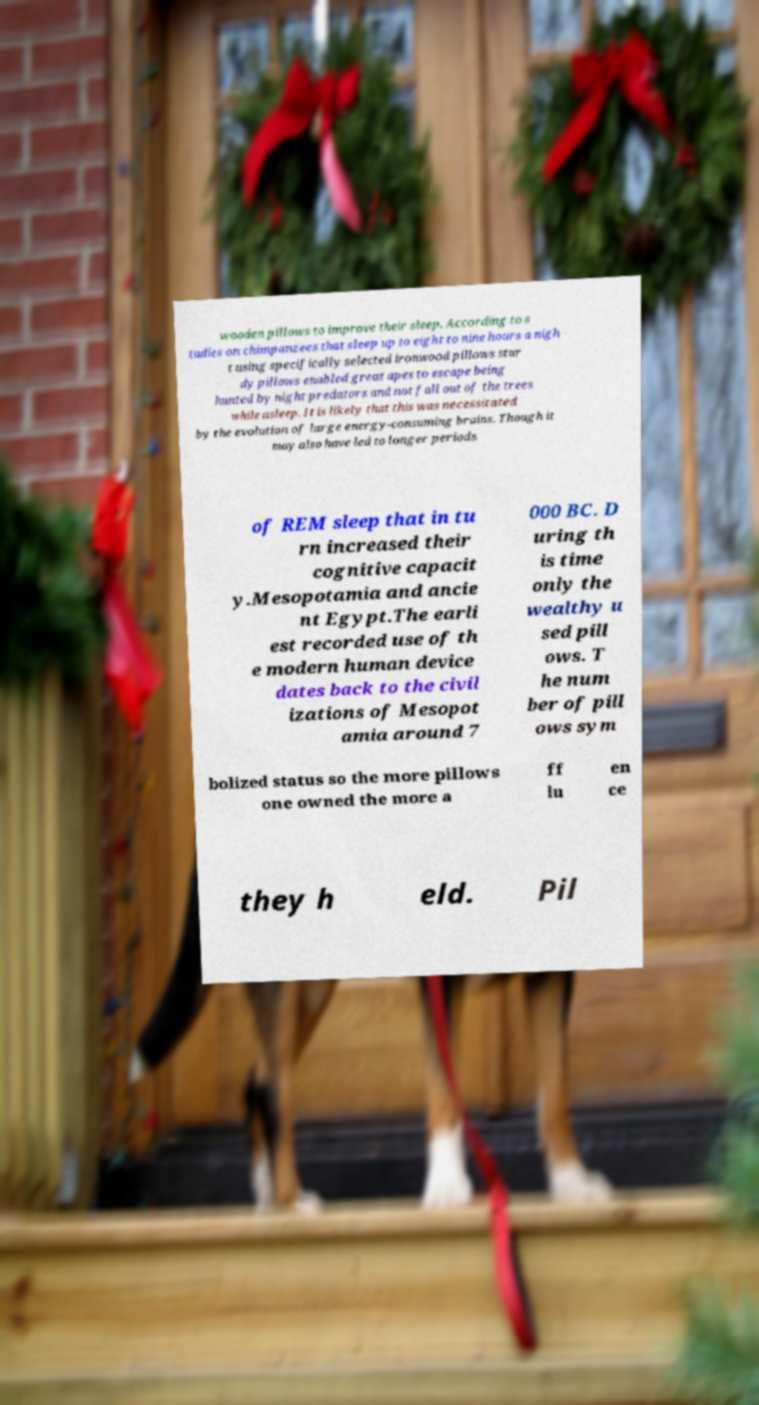Can you accurately transcribe the text from the provided image for me? wooden pillows to improve their sleep. According to s tudies on chimpanzees that sleep up to eight to nine hours a nigh t using specifically selected ironwood pillows stur dy pillows enabled great apes to escape being hunted by night predators and not fall out of the trees while asleep. It is likely that this was necessitated by the evolution of large energy-consuming brains. Though it may also have led to longer periods of REM sleep that in tu rn increased their cognitive capacit y.Mesopotamia and ancie nt Egypt.The earli est recorded use of th e modern human device dates back to the civil izations of Mesopot amia around 7 000 BC. D uring th is time only the wealthy u sed pill ows. T he num ber of pill ows sym bolized status so the more pillows one owned the more a ff lu en ce they h eld. Pil 